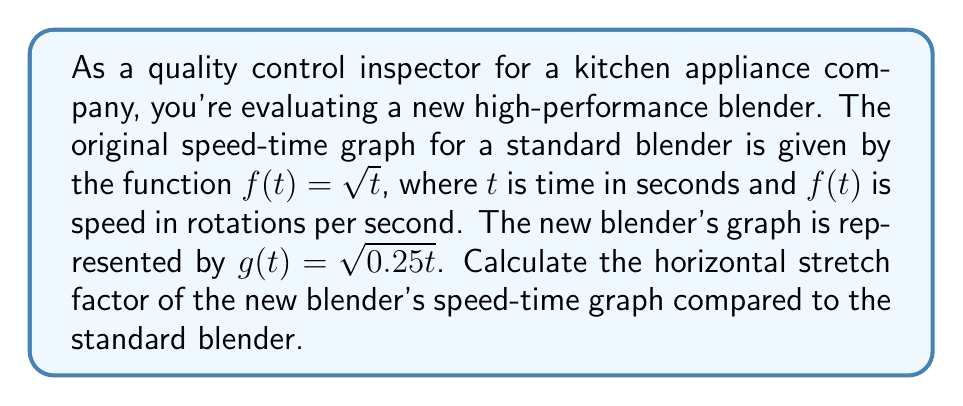Can you solve this math problem? To determine the horizontal stretch factor, we need to compare the new function $g(t)$ to the original function $f(t)$. Let's approach this step-by-step:

1) The original function is $f(t) = \sqrt{t}$

2) The new function is $g(t) = \sqrt{0.25t}$

3) To find the horizontal stretch factor, we need to rewrite $g(t)$ in terms of $f(t)$. Let's call the stretch factor $k$:

   $g(t) = f(kt)$

4) Now, let's equate these:

   $\sqrt{0.25t} = \sqrt{kt}$

5) For this to be true, the arguments must be equal:

   $0.25t = kt$

6) Solving for $k$:

   $k = 0.25 = \frac{1}{4}$

7) The horizontal stretch factor is the reciprocal of $k$:

   Horizontal stretch factor $= \frac{1}{k} = \frac{1}{0.25} = 4$

This means the graph is stretched horizontally by a factor of 4 compared to the original function.
Answer: The horizontal stretch factor is 4. 